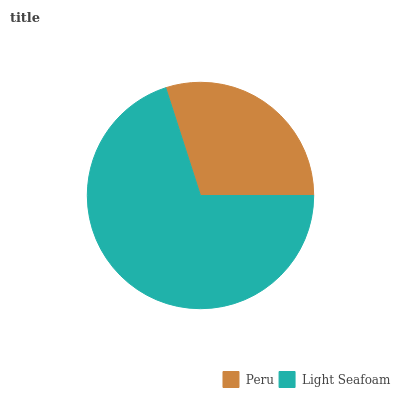Is Peru the minimum?
Answer yes or no. Yes. Is Light Seafoam the maximum?
Answer yes or no. Yes. Is Light Seafoam the minimum?
Answer yes or no. No. Is Light Seafoam greater than Peru?
Answer yes or no. Yes. Is Peru less than Light Seafoam?
Answer yes or no. Yes. Is Peru greater than Light Seafoam?
Answer yes or no. No. Is Light Seafoam less than Peru?
Answer yes or no. No. Is Light Seafoam the high median?
Answer yes or no. Yes. Is Peru the low median?
Answer yes or no. Yes. Is Peru the high median?
Answer yes or no. No. Is Light Seafoam the low median?
Answer yes or no. No. 